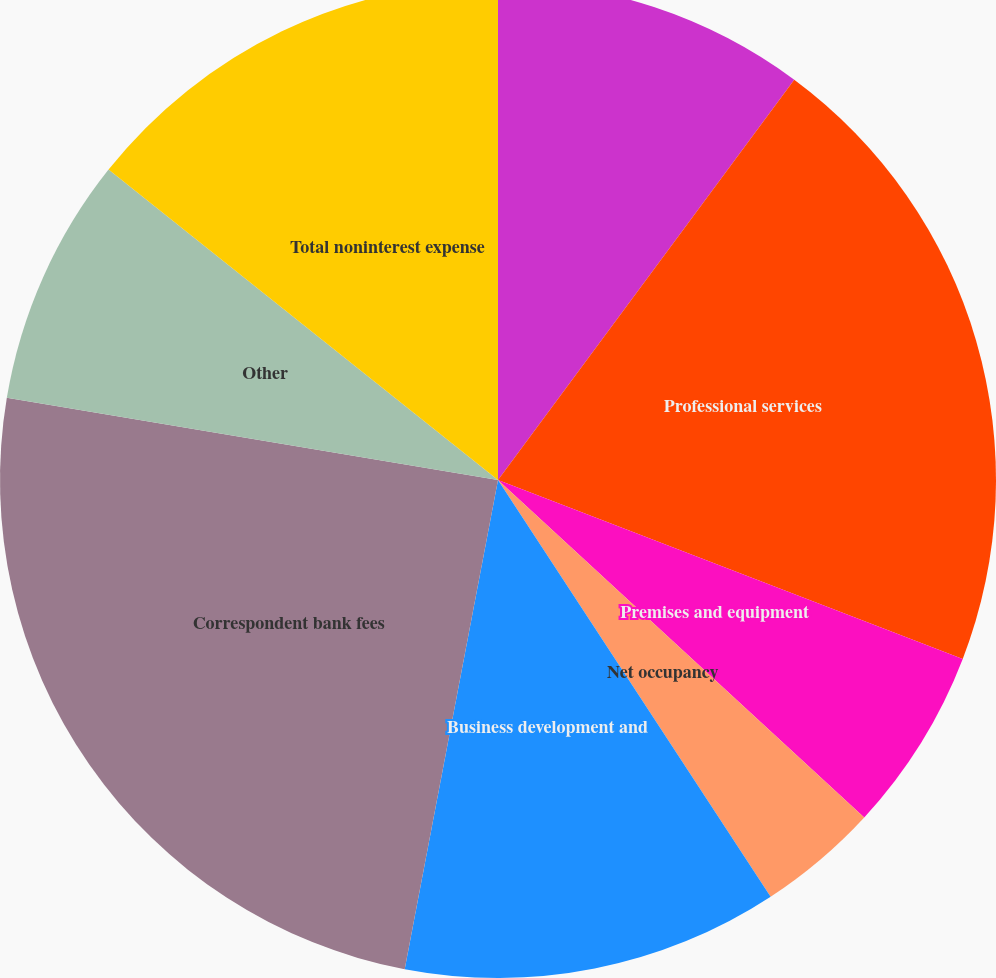<chart> <loc_0><loc_0><loc_500><loc_500><pie_chart><fcel>Compensation and benefits<fcel>Professional services<fcel>Premises and equipment<fcel>Net occupancy<fcel>Business development and<fcel>Correspondent bank fees<fcel>Other<fcel>Total noninterest expense<nl><fcel>10.14%<fcel>20.71%<fcel>6.0%<fcel>3.93%<fcel>12.22%<fcel>24.64%<fcel>8.07%<fcel>14.29%<nl></chart> 